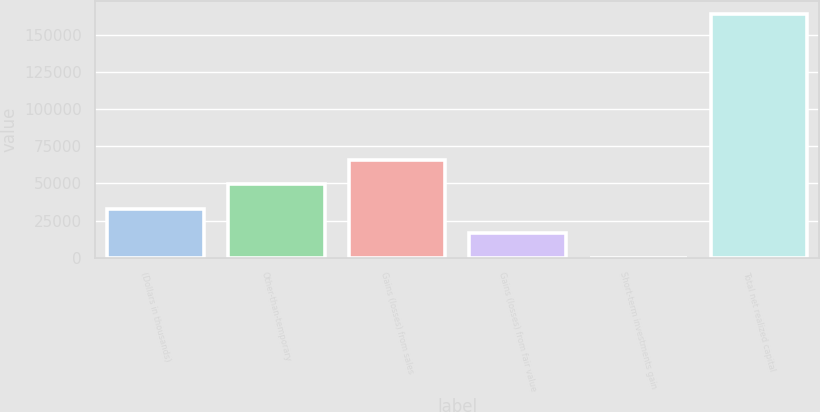Convert chart. <chart><loc_0><loc_0><loc_500><loc_500><bar_chart><fcel>(Dollars in thousands)<fcel>Other-than-temporary<fcel>Gains (losses) from sales<fcel>Gains (losses) from fair value<fcel>Short-term investments gain<fcel>Total net realized capital<nl><fcel>32892.8<fcel>49331.2<fcel>65769.6<fcel>16454.4<fcel>16<fcel>164400<nl></chart> 